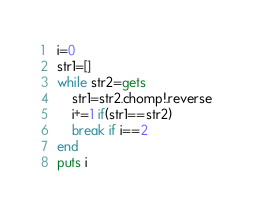Convert code to text. <code><loc_0><loc_0><loc_500><loc_500><_Ruby_>i=0
str1=[]
while str2=gets
    str1=str2.chomp!.reverse
    i+=1 if(str1==str2)
    break if i==2
end
puts i</code> 